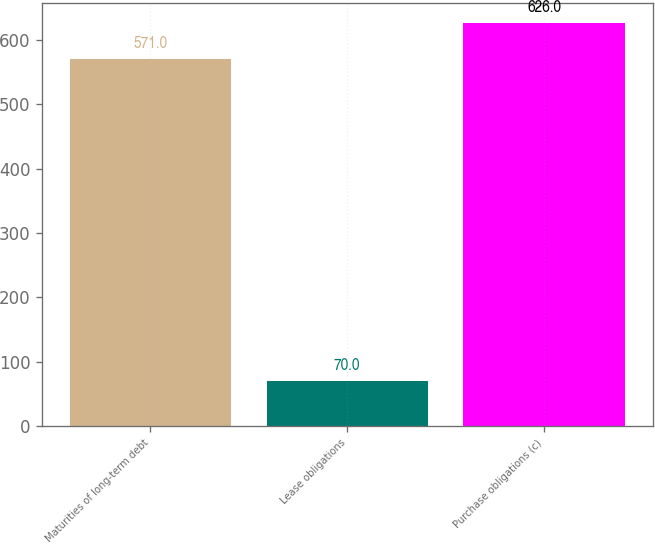Convert chart to OTSL. <chart><loc_0><loc_0><loc_500><loc_500><bar_chart><fcel>Maturities of long-term debt<fcel>Lease obligations<fcel>Purchase obligations (c)<nl><fcel>571<fcel>70<fcel>626<nl></chart> 